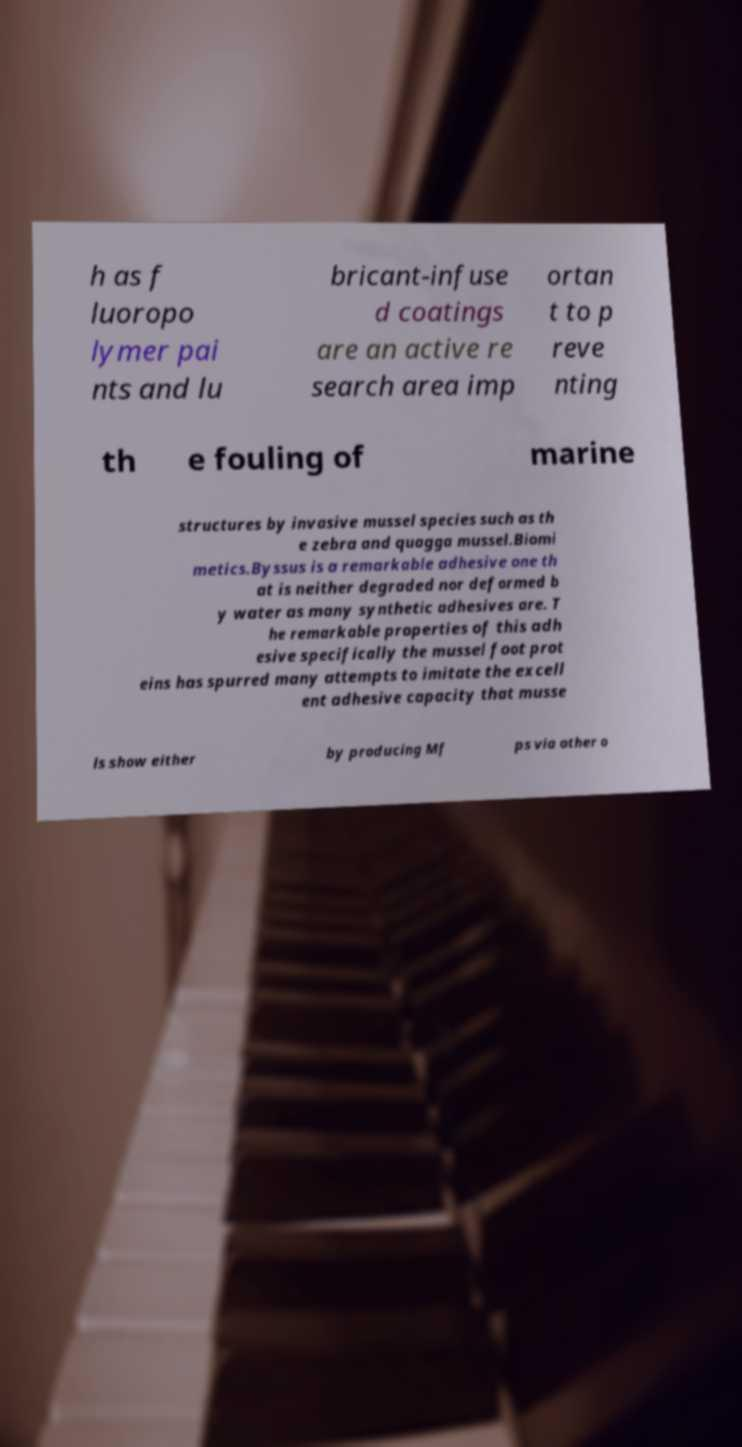There's text embedded in this image that I need extracted. Can you transcribe it verbatim? h as f luoropo lymer pai nts and lu bricant-infuse d coatings are an active re search area imp ortan t to p reve nting th e fouling of marine structures by invasive mussel species such as th e zebra and quagga mussel.Biomi metics.Byssus is a remarkable adhesive one th at is neither degraded nor deformed b y water as many synthetic adhesives are. T he remarkable properties of this adh esive specifically the mussel foot prot eins has spurred many attempts to imitate the excell ent adhesive capacity that musse ls show either by producing Mf ps via other o 